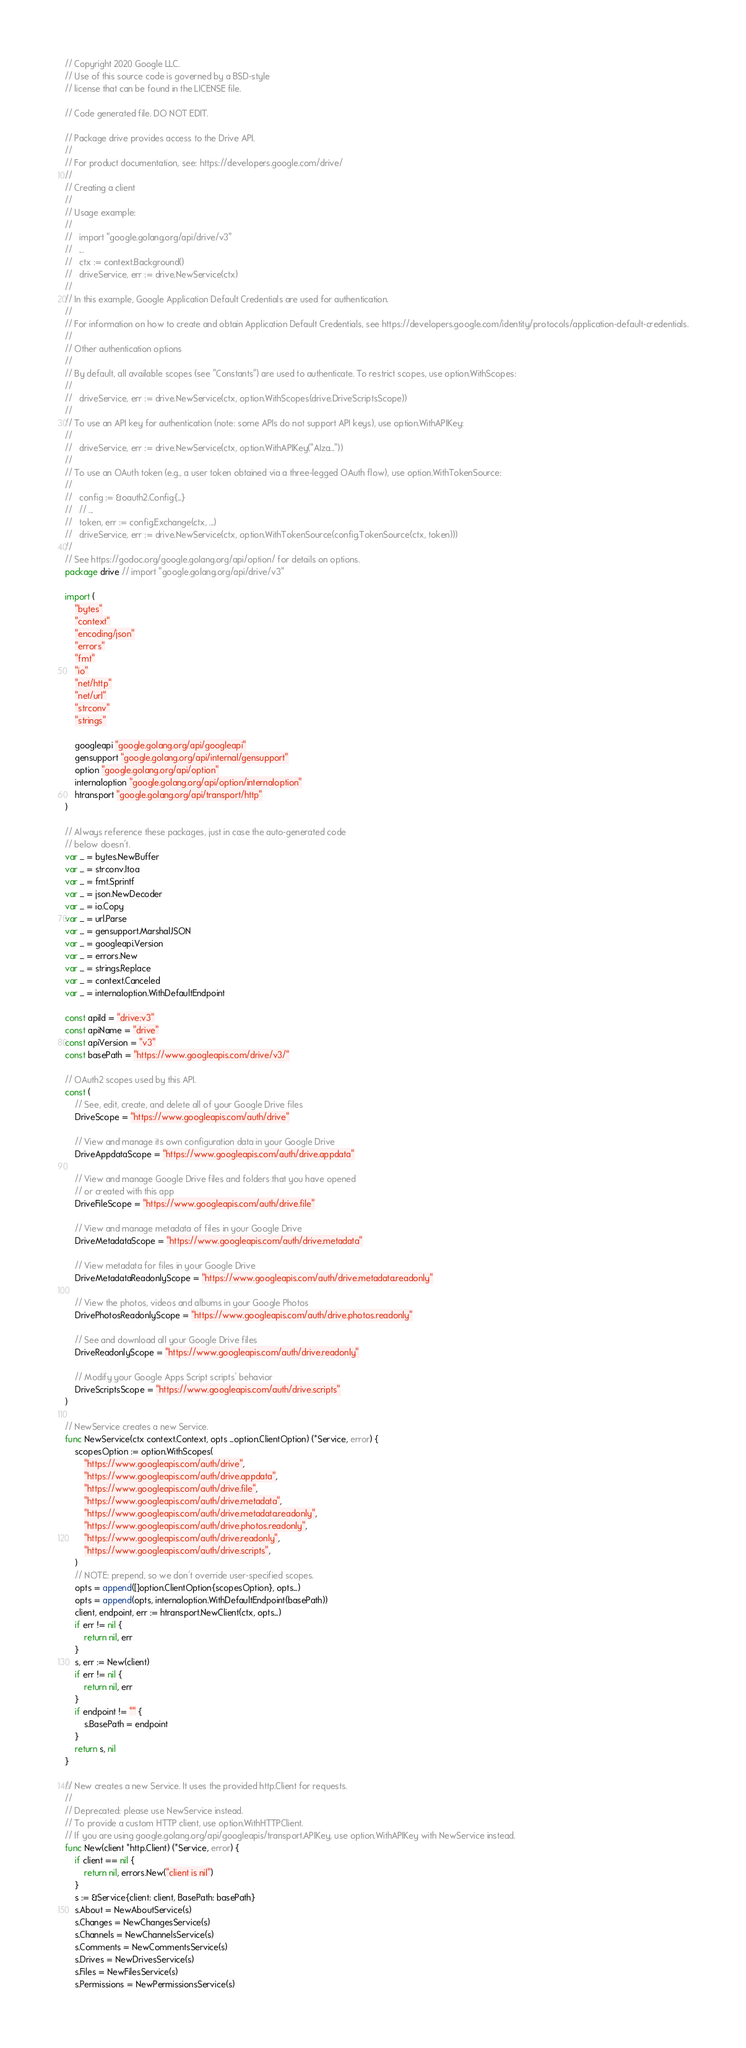Convert code to text. <code><loc_0><loc_0><loc_500><loc_500><_Go_>// Copyright 2020 Google LLC.
// Use of this source code is governed by a BSD-style
// license that can be found in the LICENSE file.

// Code generated file. DO NOT EDIT.

// Package drive provides access to the Drive API.
//
// For product documentation, see: https://developers.google.com/drive/
//
// Creating a client
//
// Usage example:
//
//   import "google.golang.org/api/drive/v3"
//   ...
//   ctx := context.Background()
//   driveService, err := drive.NewService(ctx)
//
// In this example, Google Application Default Credentials are used for authentication.
//
// For information on how to create and obtain Application Default Credentials, see https://developers.google.com/identity/protocols/application-default-credentials.
//
// Other authentication options
//
// By default, all available scopes (see "Constants") are used to authenticate. To restrict scopes, use option.WithScopes:
//
//   driveService, err := drive.NewService(ctx, option.WithScopes(drive.DriveScriptsScope))
//
// To use an API key for authentication (note: some APIs do not support API keys), use option.WithAPIKey:
//
//   driveService, err := drive.NewService(ctx, option.WithAPIKey("AIza..."))
//
// To use an OAuth token (e.g., a user token obtained via a three-legged OAuth flow), use option.WithTokenSource:
//
//   config := &oauth2.Config{...}
//   // ...
//   token, err := config.Exchange(ctx, ...)
//   driveService, err := drive.NewService(ctx, option.WithTokenSource(config.TokenSource(ctx, token)))
//
// See https://godoc.org/google.golang.org/api/option/ for details on options.
package drive // import "google.golang.org/api/drive/v3"

import (
	"bytes"
	"context"
	"encoding/json"
	"errors"
	"fmt"
	"io"
	"net/http"
	"net/url"
	"strconv"
	"strings"

	googleapi "google.golang.org/api/googleapi"
	gensupport "google.golang.org/api/internal/gensupport"
	option "google.golang.org/api/option"
	internaloption "google.golang.org/api/option/internaloption"
	htransport "google.golang.org/api/transport/http"
)

// Always reference these packages, just in case the auto-generated code
// below doesn't.
var _ = bytes.NewBuffer
var _ = strconv.Itoa
var _ = fmt.Sprintf
var _ = json.NewDecoder
var _ = io.Copy
var _ = url.Parse
var _ = gensupport.MarshalJSON
var _ = googleapi.Version
var _ = errors.New
var _ = strings.Replace
var _ = context.Canceled
var _ = internaloption.WithDefaultEndpoint

const apiId = "drive:v3"
const apiName = "drive"
const apiVersion = "v3"
const basePath = "https://www.googleapis.com/drive/v3/"

// OAuth2 scopes used by this API.
const (
	// See, edit, create, and delete all of your Google Drive files
	DriveScope = "https://www.googleapis.com/auth/drive"

	// View and manage its own configuration data in your Google Drive
	DriveAppdataScope = "https://www.googleapis.com/auth/drive.appdata"

	// View and manage Google Drive files and folders that you have opened
	// or created with this app
	DriveFileScope = "https://www.googleapis.com/auth/drive.file"

	// View and manage metadata of files in your Google Drive
	DriveMetadataScope = "https://www.googleapis.com/auth/drive.metadata"

	// View metadata for files in your Google Drive
	DriveMetadataReadonlyScope = "https://www.googleapis.com/auth/drive.metadata.readonly"

	// View the photos, videos and albums in your Google Photos
	DrivePhotosReadonlyScope = "https://www.googleapis.com/auth/drive.photos.readonly"

	// See and download all your Google Drive files
	DriveReadonlyScope = "https://www.googleapis.com/auth/drive.readonly"

	// Modify your Google Apps Script scripts' behavior
	DriveScriptsScope = "https://www.googleapis.com/auth/drive.scripts"
)

// NewService creates a new Service.
func NewService(ctx context.Context, opts ...option.ClientOption) (*Service, error) {
	scopesOption := option.WithScopes(
		"https://www.googleapis.com/auth/drive",
		"https://www.googleapis.com/auth/drive.appdata",
		"https://www.googleapis.com/auth/drive.file",
		"https://www.googleapis.com/auth/drive.metadata",
		"https://www.googleapis.com/auth/drive.metadata.readonly",
		"https://www.googleapis.com/auth/drive.photos.readonly",
		"https://www.googleapis.com/auth/drive.readonly",
		"https://www.googleapis.com/auth/drive.scripts",
	)
	// NOTE: prepend, so we don't override user-specified scopes.
	opts = append([]option.ClientOption{scopesOption}, opts...)
	opts = append(opts, internaloption.WithDefaultEndpoint(basePath))
	client, endpoint, err := htransport.NewClient(ctx, opts...)
	if err != nil {
		return nil, err
	}
	s, err := New(client)
	if err != nil {
		return nil, err
	}
	if endpoint != "" {
		s.BasePath = endpoint
	}
	return s, nil
}

// New creates a new Service. It uses the provided http.Client for requests.
//
// Deprecated: please use NewService instead.
// To provide a custom HTTP client, use option.WithHTTPClient.
// If you are using google.golang.org/api/googleapis/transport.APIKey, use option.WithAPIKey with NewService instead.
func New(client *http.Client) (*Service, error) {
	if client == nil {
		return nil, errors.New("client is nil")
	}
	s := &Service{client: client, BasePath: basePath}
	s.About = NewAboutService(s)
	s.Changes = NewChangesService(s)
	s.Channels = NewChannelsService(s)
	s.Comments = NewCommentsService(s)
	s.Drives = NewDrivesService(s)
	s.Files = NewFilesService(s)
	s.Permissions = NewPermissionsService(s)</code> 